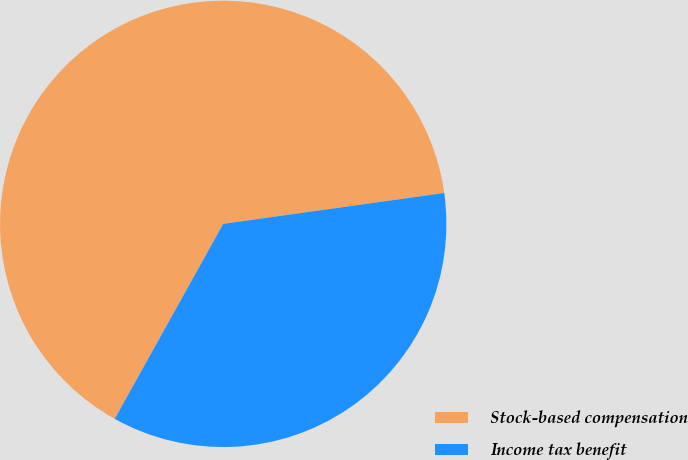Convert chart to OTSL. <chart><loc_0><loc_0><loc_500><loc_500><pie_chart><fcel>Stock-based compensation<fcel>Income tax benefit<nl><fcel>64.71%<fcel>35.29%<nl></chart> 